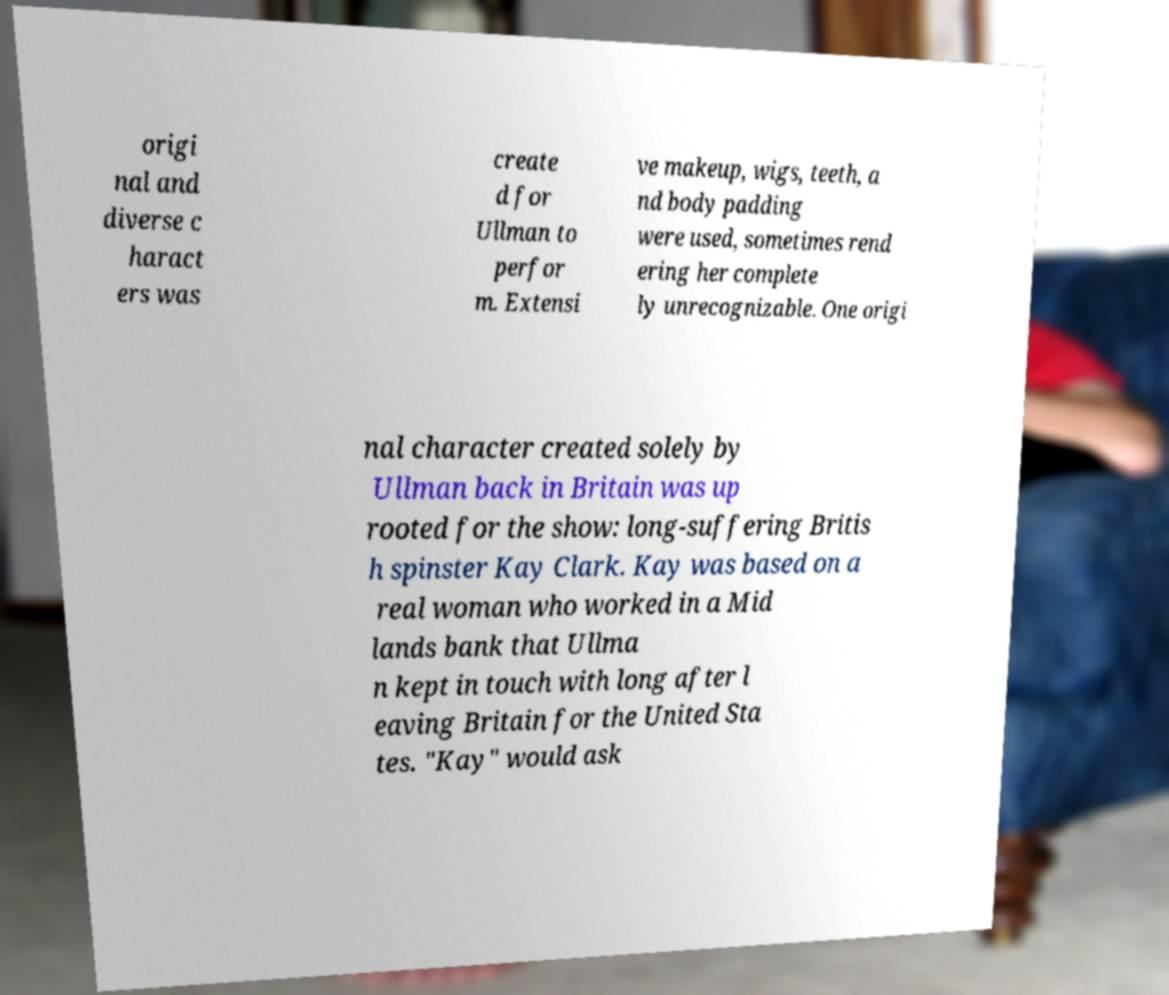Please read and relay the text visible in this image. What does it say? origi nal and diverse c haract ers was create d for Ullman to perfor m. Extensi ve makeup, wigs, teeth, a nd body padding were used, sometimes rend ering her complete ly unrecognizable. One origi nal character created solely by Ullman back in Britain was up rooted for the show: long-suffering Britis h spinster Kay Clark. Kay was based on a real woman who worked in a Mid lands bank that Ullma n kept in touch with long after l eaving Britain for the United Sta tes. "Kay" would ask 